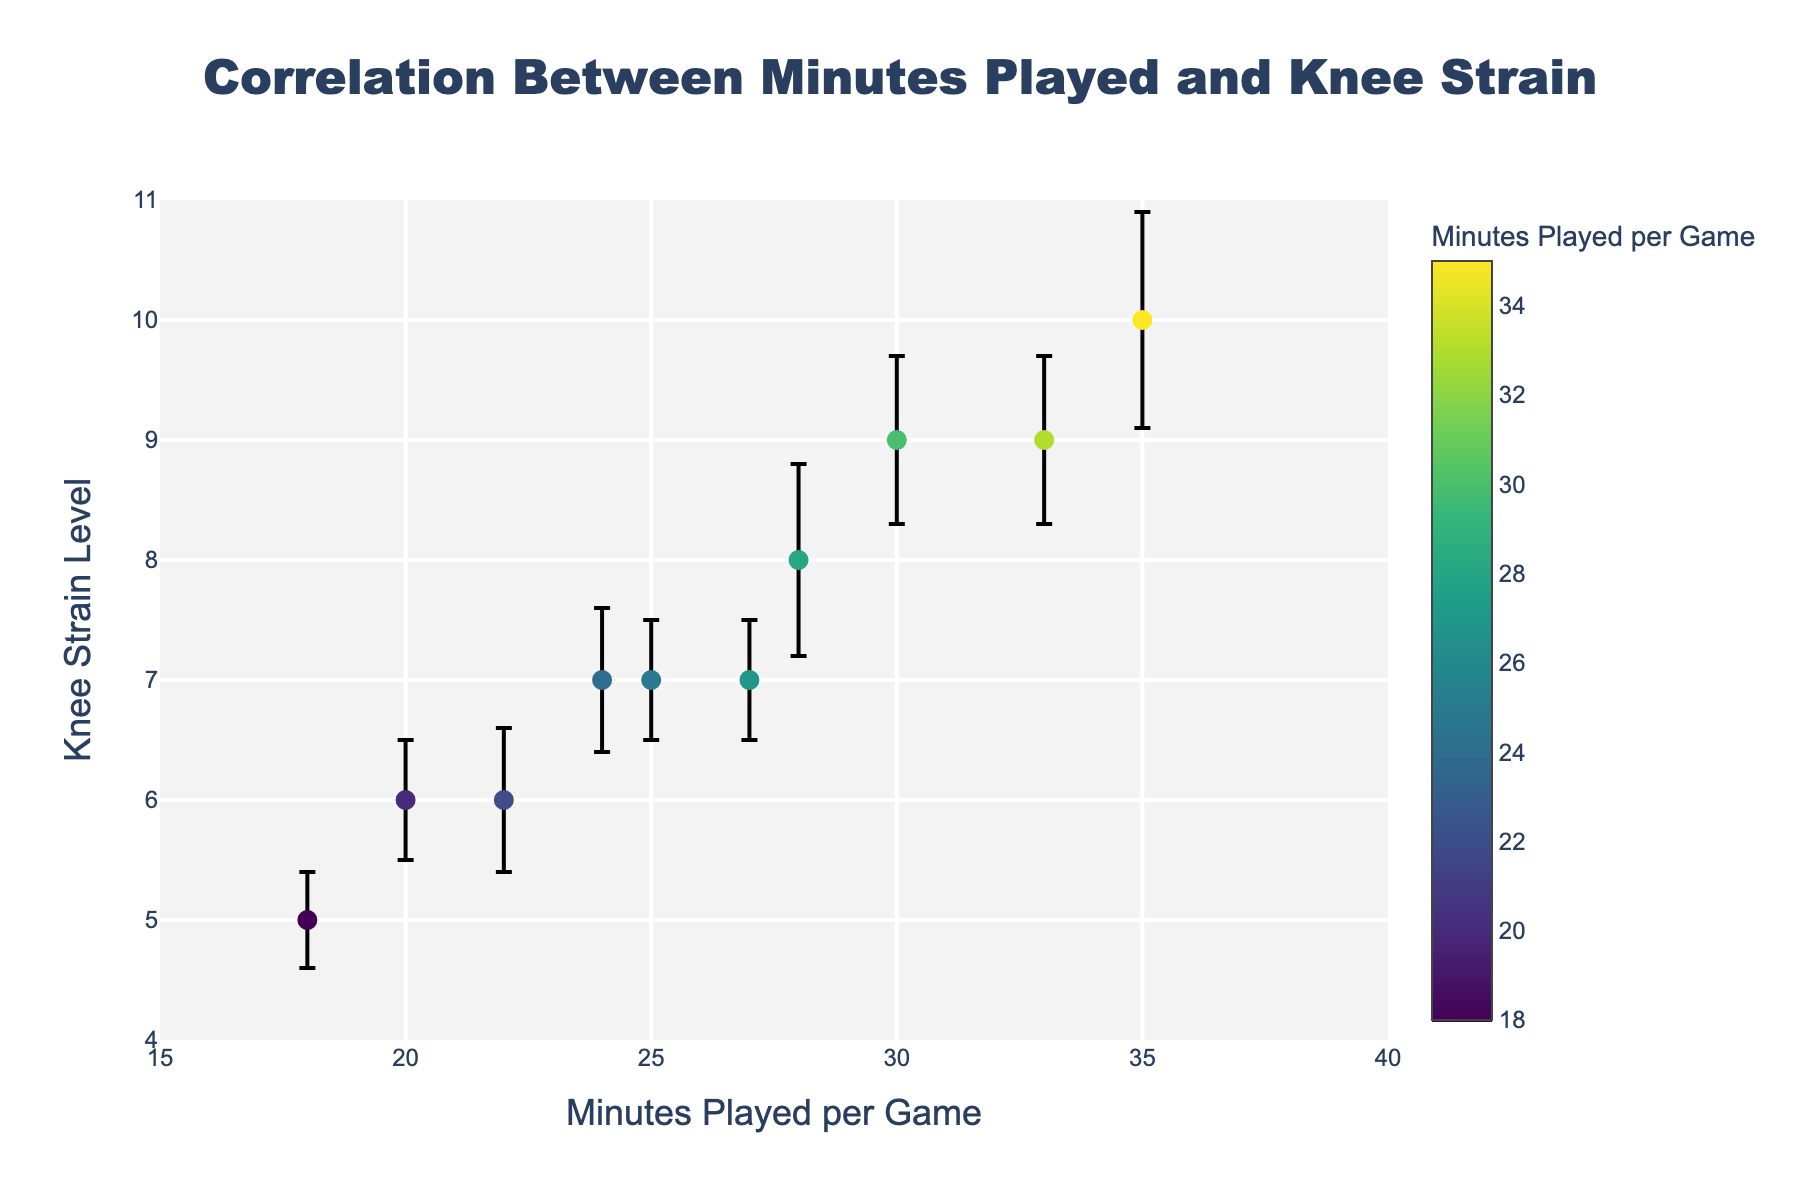How many data points are shown in the scatter plot? Count the number of markers in the scatter plot. There are 10 players, so there should be 10 data points.
Answer: 10 What is the title of the scatter plot? The title is shown prominently at the top of the plot.
Answer: Correlation Between Minutes Played and Knee Strain Which player has the highest knee strain level? Look at the y-axis for the highest knee strain level value and identify the corresponding player's data point.
Answer: James White What is the range of the x-axis (Minutes Played per Game)? Observe the values on the x-axis from the lowest to the highest tick marks.
Answer: 15 to 40 What is the average knee strain level for players who play more than 25 minutes per game? Identify players with more than 25 minutes per game (\(John Smith\), \(Michael Brown\), \(James White\), \(Robert Harris\), \(Kevin Clark\), \(Charles Lewis\)) and calculate the average of their knee strain levels (\(7, 9, 10, 8, 7, 9\)). Sum is \(7 + 9 + 10 + 8 + 7 + 9 = 50\). Average is \(50 / 6 = 8.33\).
Answer: 8.33 Who has the smallest standard deviation in knee strain levels? Check the error bars and corresponding values to find the smallest standard deviation.
Answer: Chris Johnson How does the knee strain level of David Lee compare to that of Mark Davis? Find both players' markers to compare their y-values (knee strain levels). \(David Lee: 6\), \(Mark Davis: 6\).
Answer: Equal What is the correlation trend between minutes played and knee strain levels based on the plot? Observe the general direction of the data points; whether they trend upwards or downwards.
Answer: Positive correlation Which player has the highest standard deviation in knee strain levels, and what is that value? Find the error bar with the largest value and identify the corresponding player.
Answer: James White, 0.9 What is the difference in knee strain levels between Michael Brown and Brian Walker? Compare the y-values of Michael Brown (\(9\)) and Brian Walker (\(7\)). The difference is \(9 - 7\).
Answer: 2 